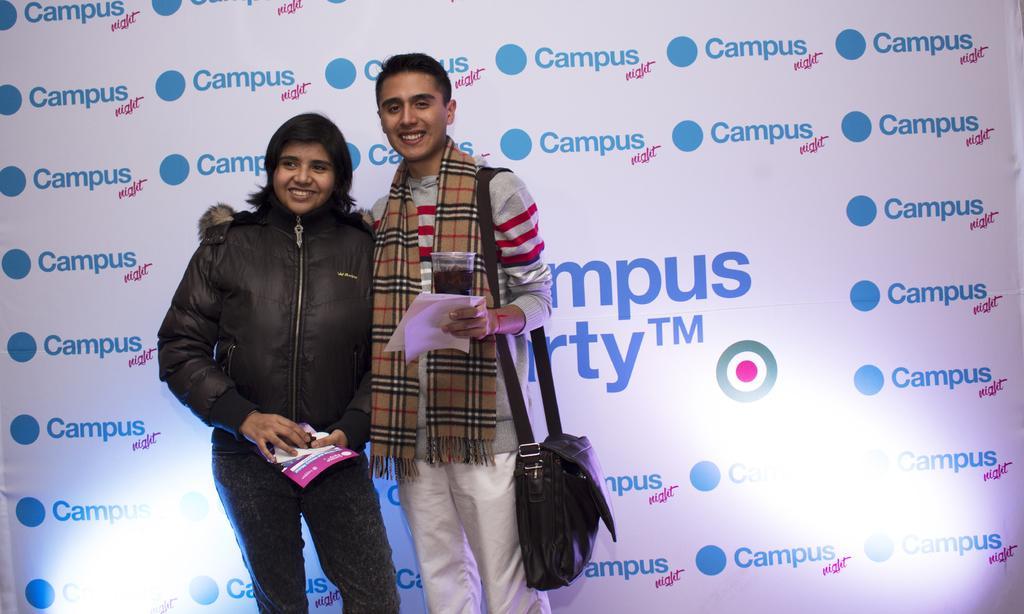Describe this image in one or two sentences. In this picture we can see there are two people standing and holding papers and behind the people there is a board. 